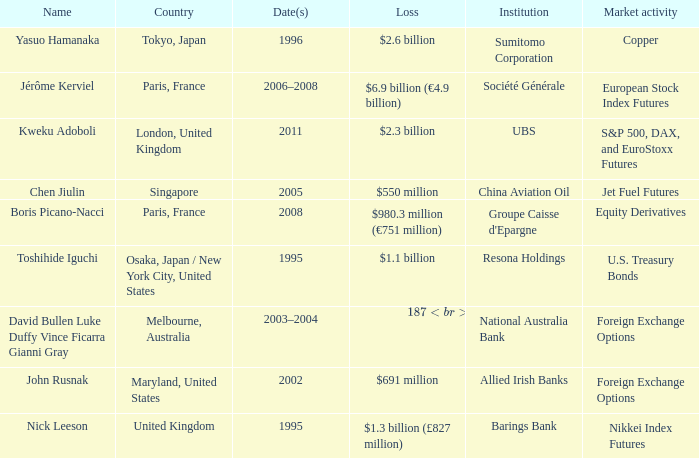What was the loss for Boris Picano-Nacci? $980.3 million (€751 million). Give me the full table as a dictionary. {'header': ['Name', 'Country', 'Date(s)', 'Loss', 'Institution', 'Market activity'], 'rows': [['Yasuo Hamanaka', 'Tokyo, Japan', '1996', '$2.6 billion', 'Sumitomo Corporation', 'Copper'], ['Jérôme Kerviel', 'Paris, France', '2006–2008', '$6.9 billion (€4.9 billion)', 'Société Générale', 'European Stock Index Futures'], ['Kweku Adoboli', 'London, United Kingdom', '2011', '$2.3 billion', 'UBS', 'S&P 500, DAX, and EuroStoxx Futures'], ['Chen Jiulin', 'Singapore', '2005', '$550 million', 'China Aviation Oil', 'Jet Fuel Futures'], ['Boris Picano-Nacci', 'Paris, France', '2008', '$980.3 million (€751 million)', "Groupe Caisse d'Epargne", 'Equity Derivatives'], ['Toshihide Iguchi', 'Osaka, Japan / New York City, United States', '1995', '$1.1 billion', 'Resona Holdings', 'U.S. Treasury Bonds'], ['David Bullen Luke Duffy Vince Ficarra Gianni Gray', 'Melbourne, Australia', '2003–2004', '$187 million (A$360 million)', 'National Australia Bank', 'Foreign Exchange Options'], ['John Rusnak', 'Maryland, United States', '2002', '$691 million', 'Allied Irish Banks', 'Foreign Exchange Options'], ['Nick Leeson', 'United Kingdom', '1995', '$1.3 billion (£827 million)', 'Barings Bank', 'Nikkei Index Futures']]} 